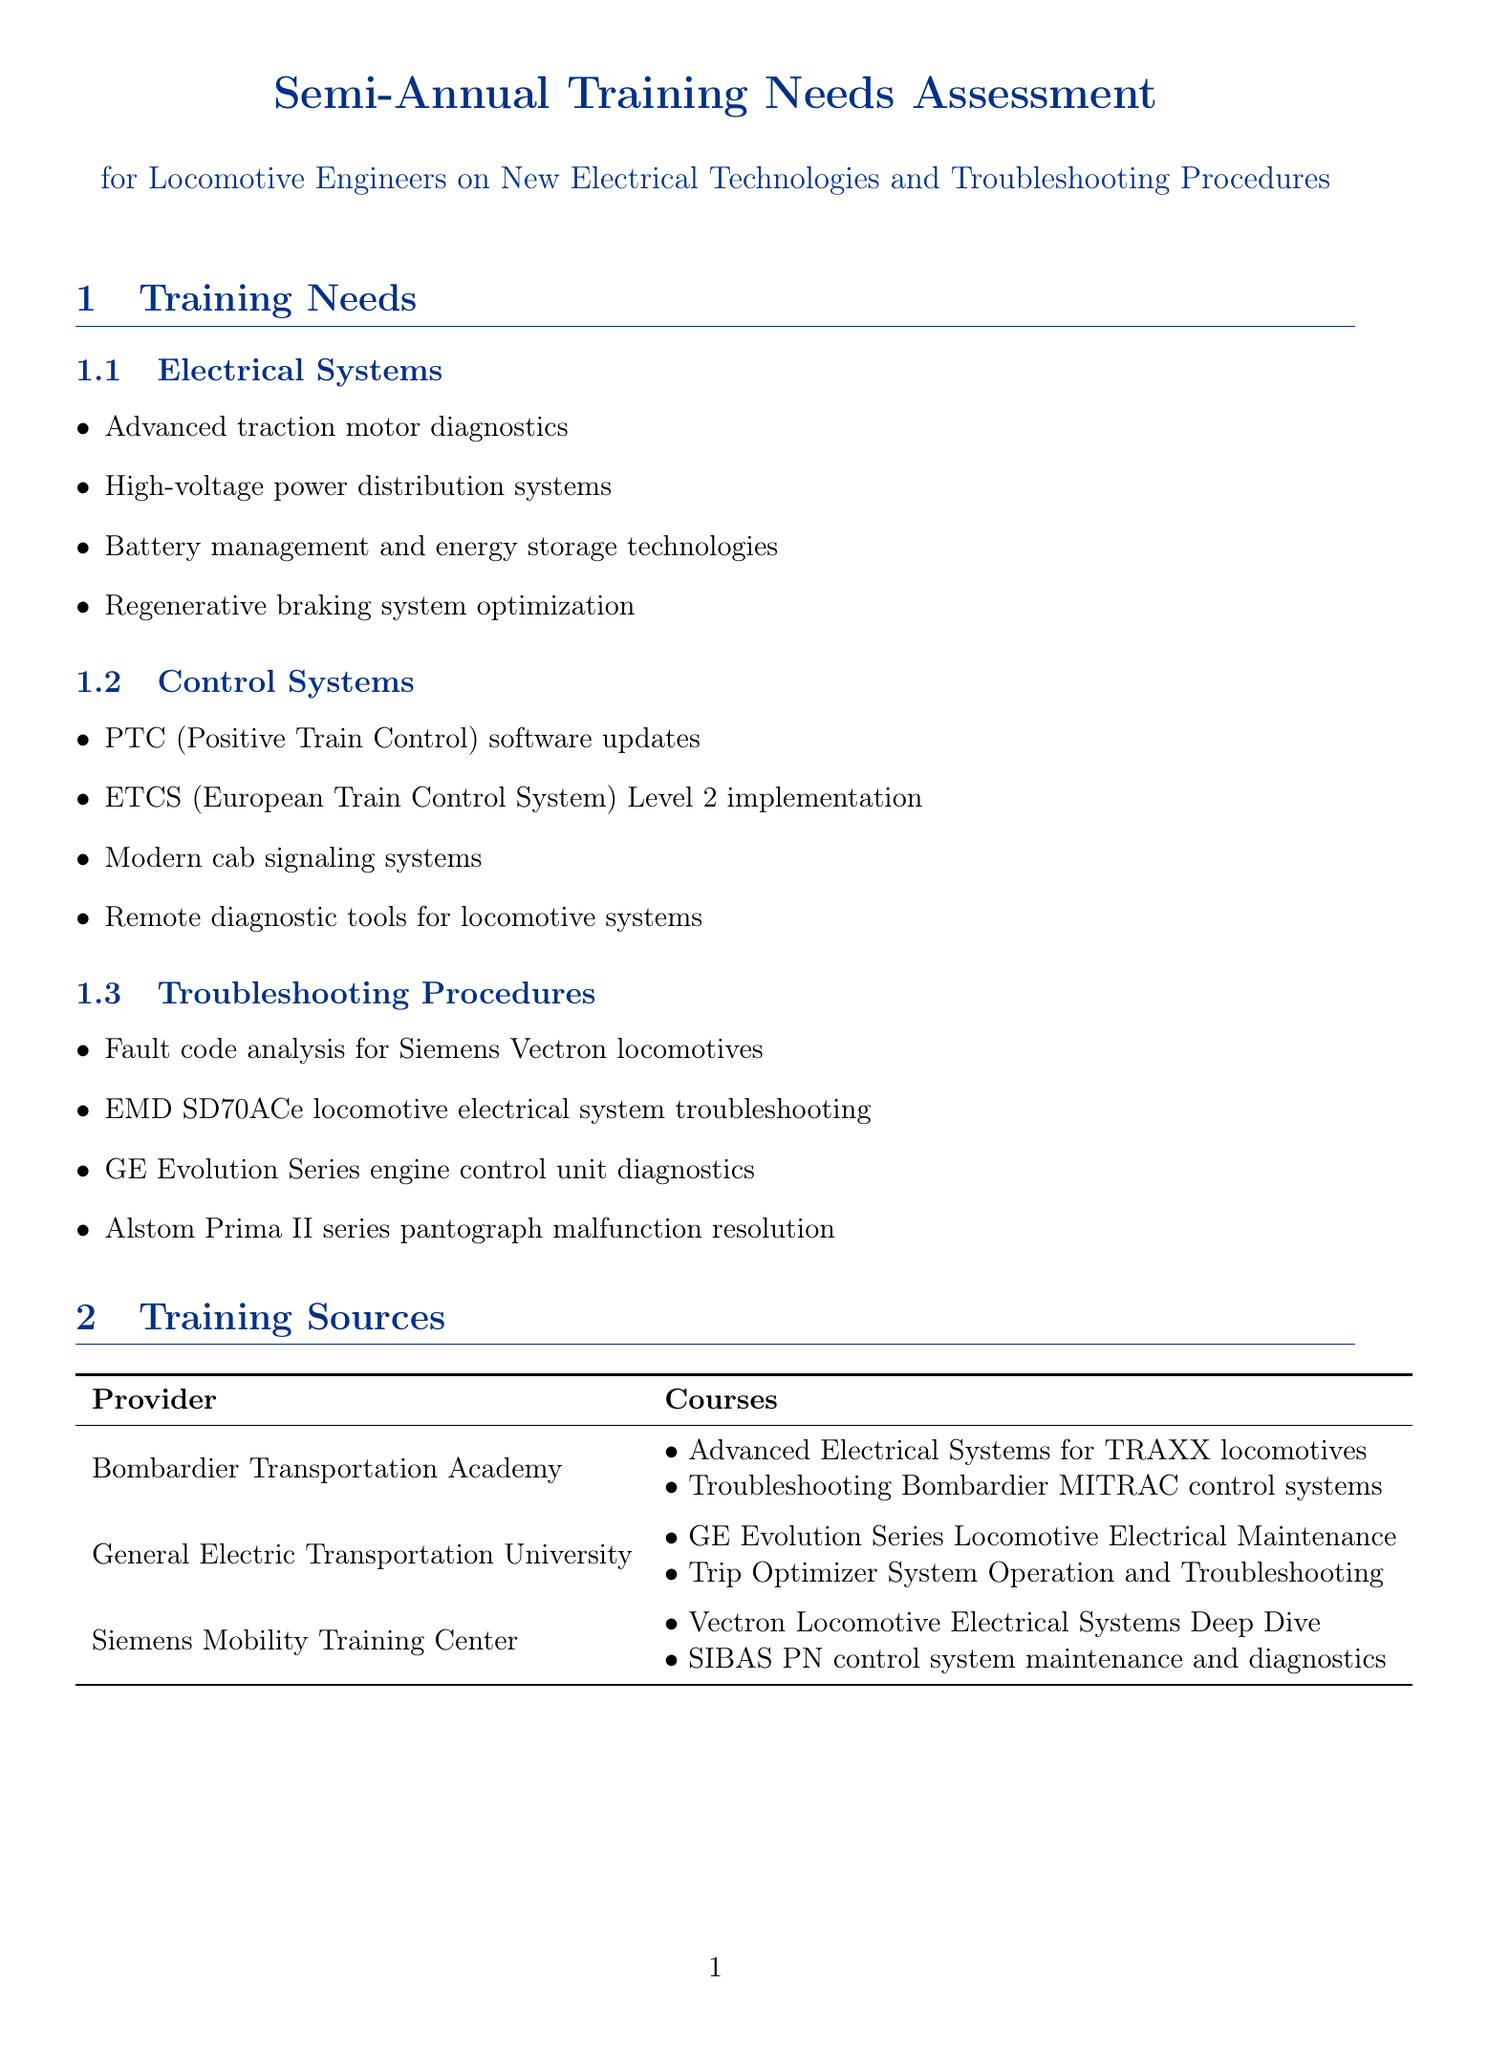What are the topics under Electrical Systems? The topics listed under Electrical Systems include advanced traction motor diagnostics, high-voltage power distribution systems, battery management and energy storage technologies, and regenerative braking system optimization.
Answer: Advanced traction motor diagnostics, high-voltage power distribution systems, battery management and energy storage technologies, regenerative braking system optimization What is the target for electrical system failure rate? The target for electrical system failure rate is specified in the performance metrics section. It states that the goal is to have less than 0.5 failures for every 100,000 km.
Answer: Less than 0.5 failures per 100,000 km What training source offers courses on Vectron locomotive electrical systems? The source that offers courses on Vectron locomotive electrical systems is identified in the training sources section. It is the Siemens Mobility Training Center.
Answer: Siemens Mobility Training Center What is the impact of the trend "Increased electrification of rail networks"? The impact of the trend is mentioned in the industry trends section. The necessity for enhanced knowledge of catenary systems and pantograph interactions is highlighted.
Answer: Need for enhanced knowledge of catenary systems and pantograph interactions Which safety topic addresses updated protocols for high-voltage systems? The safety topic that addresses updated protocols for working with high-voltage systems is detailed in the safety considerations section. It is titled high-voltage safety procedures.
Answer: High-voltage safety procedures What percentage is the target for successful fault diagnosis rate? The target for successful fault diagnosis rate is mentioned in the performance metrics section. It states that the goal is to achieve 95% accuracy in identifying the root cause of electrical issues.
Answer: 95% What is the focus of collaboration with Hitachi Rail? The collaboration opportunity involving Hitachi Rail specifies the theme of the seminar aimed at electrical architecture and troubleshooting for the AT300 series train.
Answer: Seminar on AT300 series train electrical architecture and troubleshooting What are the updated protocols for working with overhead lines? The updated protocols for working with overhead lines are described under safety considerations, stating main safety procedures for high-voltage systems.
Answer: Updated protocols for working with 25kV AC overhead lines and 3kV DC systems What training does the General Electric Transportation University offer? Within the training sources section, two significant offerings from the General Electric Transportation University are identified, which focus on GE Evolution Series locomotive electrical maintenance and Trip Optimizer system operation.
Answer: GE Evolution Series Locomotive Electrical Maintenance, Trip Optimizer System Operation and Troubleshooting 